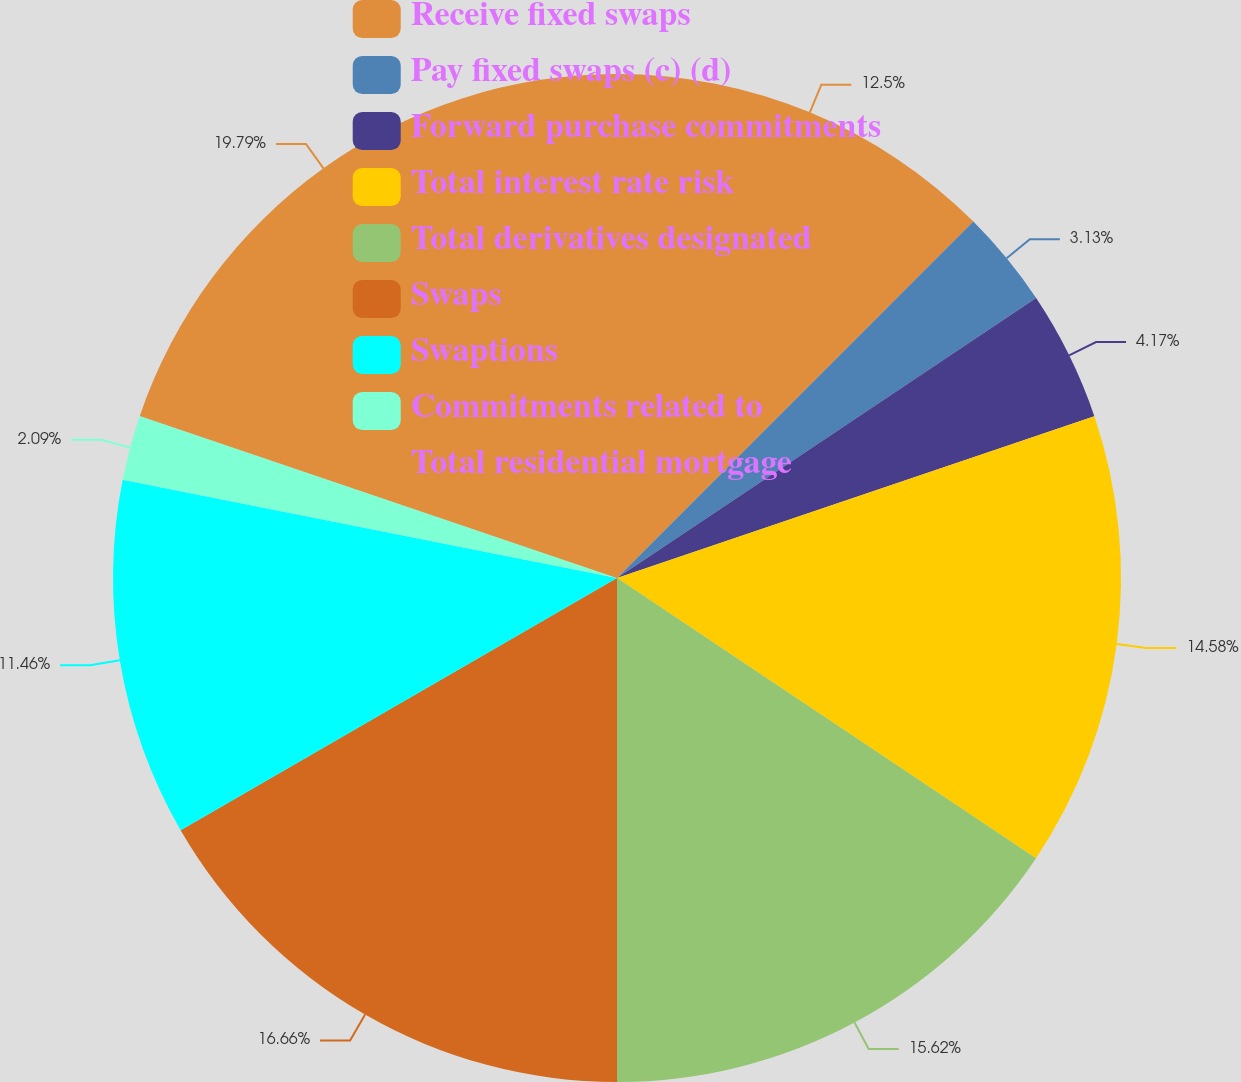Convert chart. <chart><loc_0><loc_0><loc_500><loc_500><pie_chart><fcel>Receive fixed swaps<fcel>Pay fixed swaps (c) (d)<fcel>Forward purchase commitments<fcel>Total interest rate risk<fcel>Total derivatives designated<fcel>Swaps<fcel>Swaptions<fcel>Commitments related to<fcel>Total residential mortgage<nl><fcel>12.5%<fcel>3.13%<fcel>4.17%<fcel>14.58%<fcel>15.62%<fcel>16.66%<fcel>11.46%<fcel>2.09%<fcel>19.79%<nl></chart> 